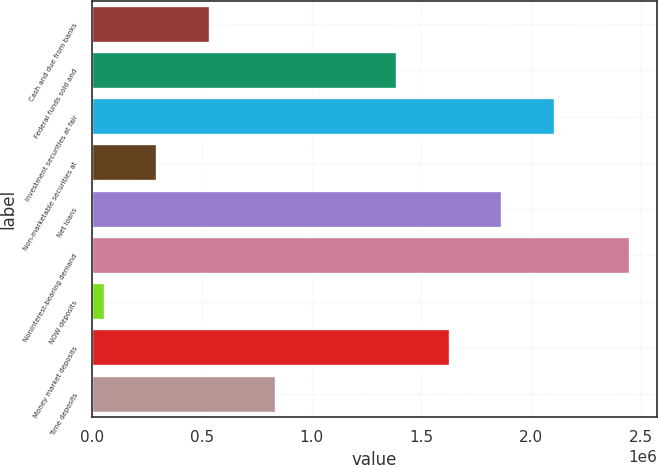Convert chart to OTSL. <chart><loc_0><loc_0><loc_500><loc_500><bar_chart><fcel>Cash and due from banks<fcel>Federal funds sold and<fcel>Investment securities at fair<fcel>Non-marketable securities at<fcel>Net loans<fcel>Noninterest-bearing demand<fcel>NOW deposits<fcel>Money market deposits<fcel>Time deposits<nl><fcel>536037<fcel>1.38973e+06<fcel>2.107e+06<fcel>296947<fcel>1.86791e+06<fcel>2.44876e+06<fcel>57857<fcel>1.62882e+06<fcel>836081<nl></chart> 